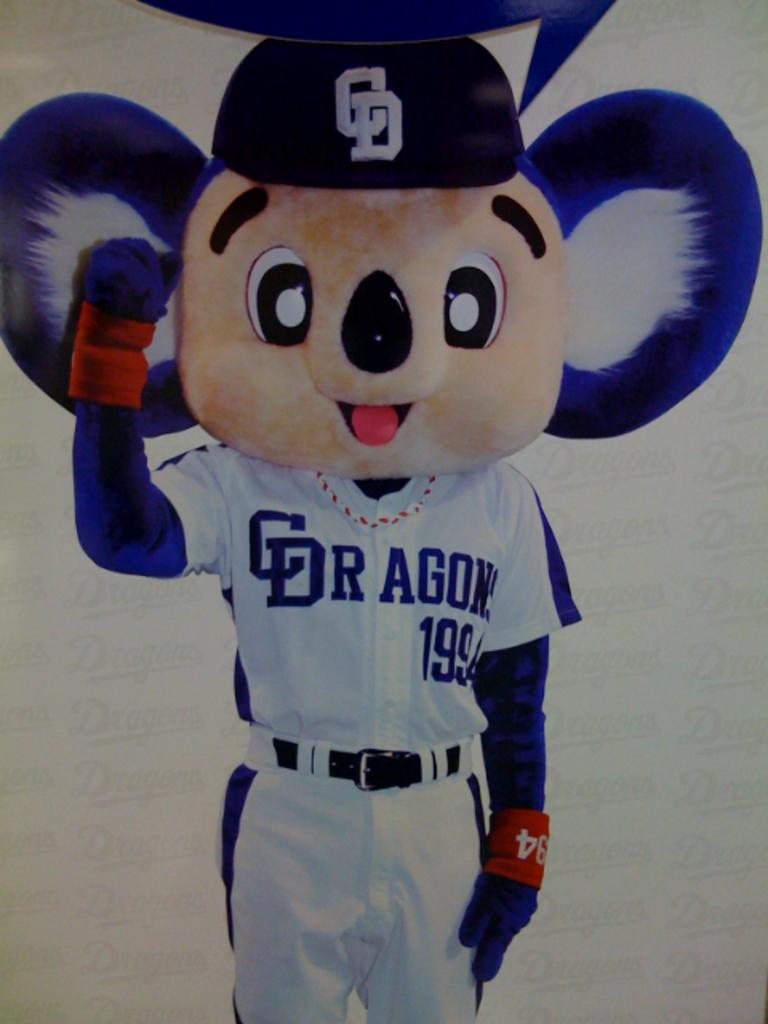<image>
Write a terse but informative summary of the picture. A mouse mascot wearing a blue and white uniform that says Dragons 1994 